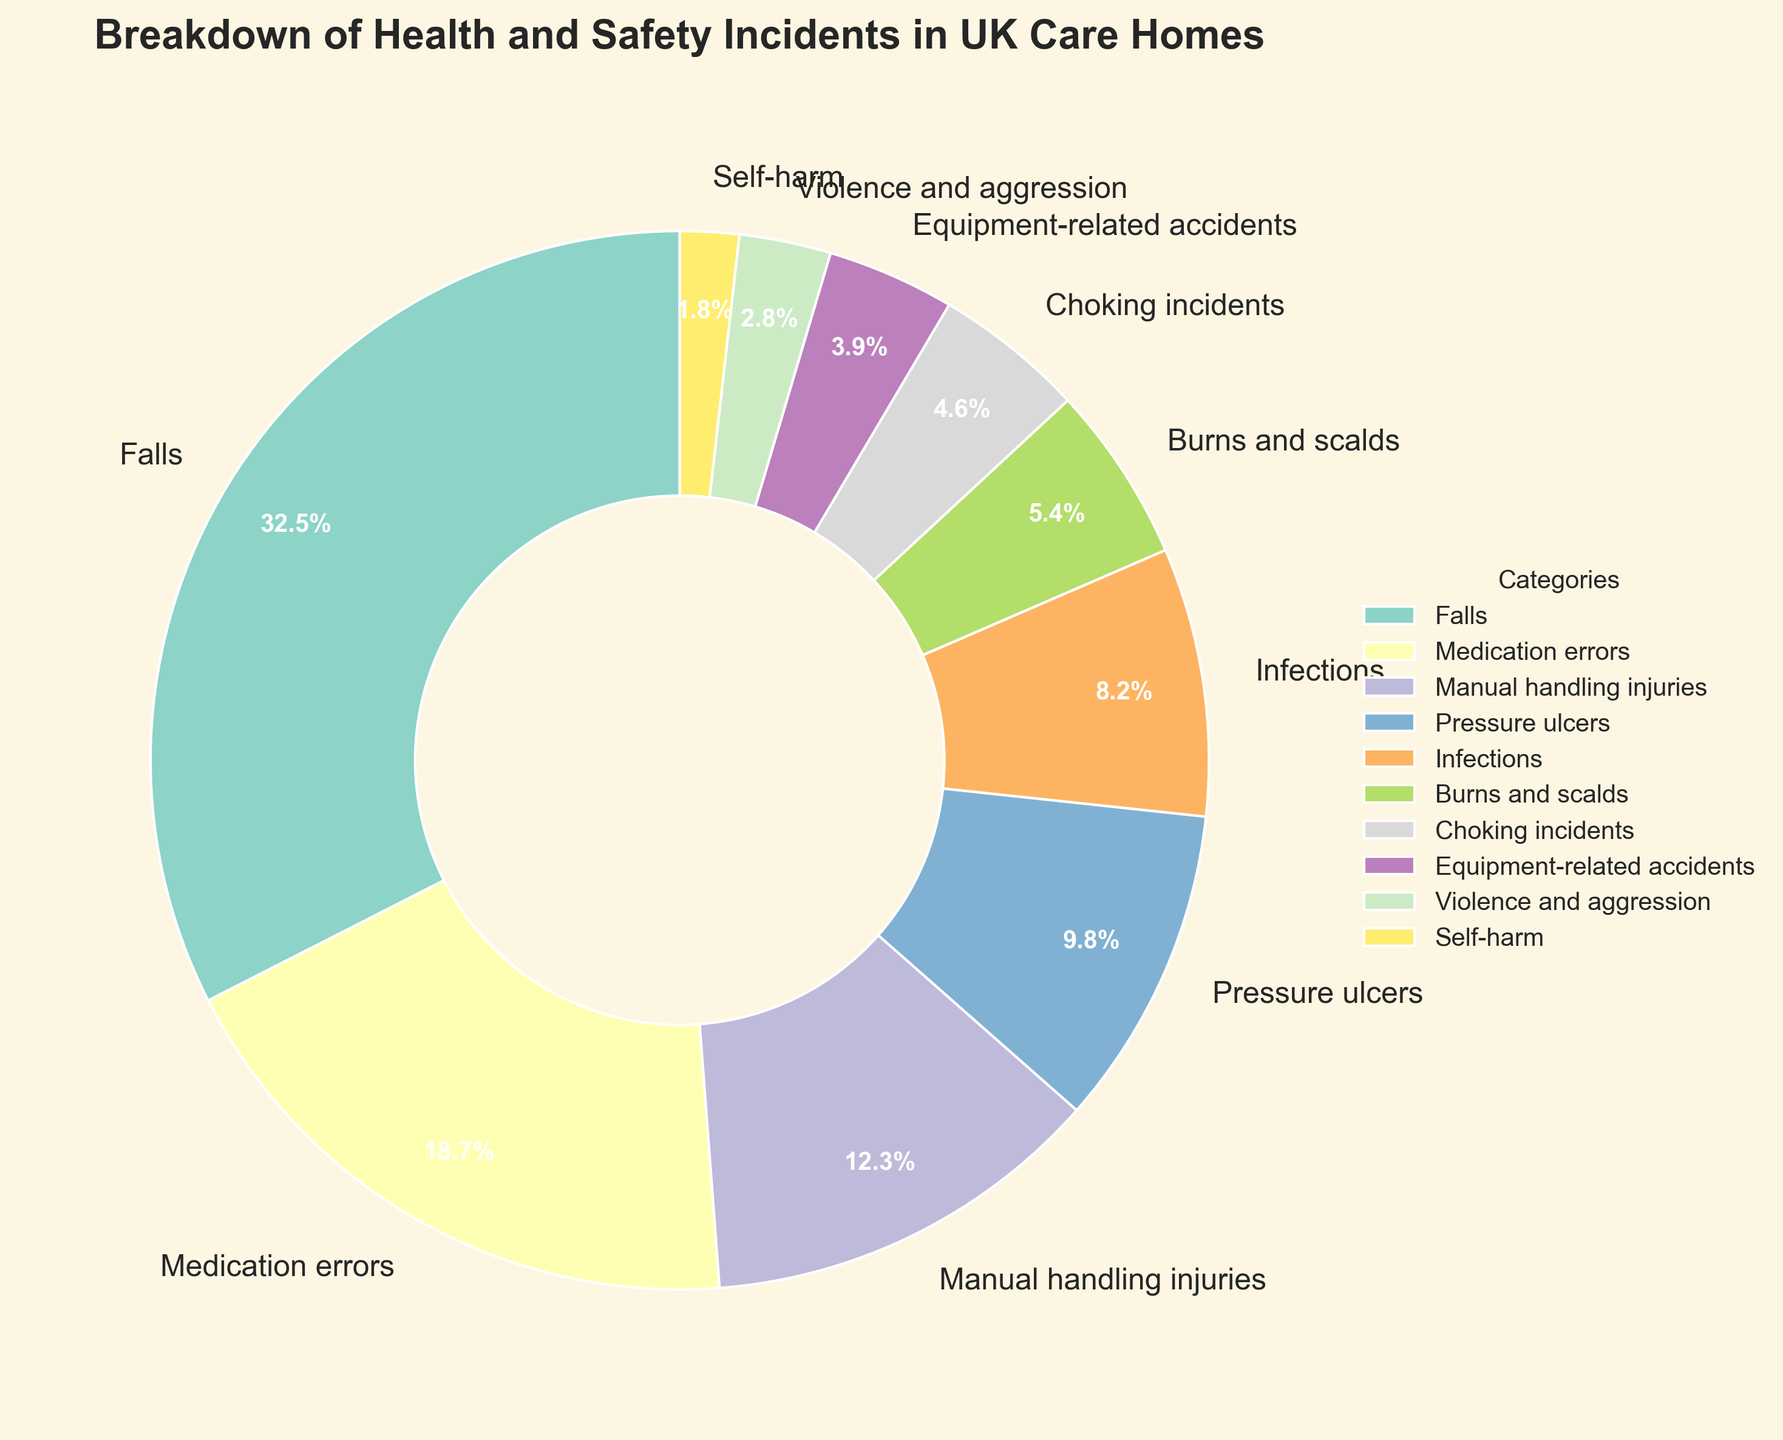How many categories have a percentage greater than 10%? Check the percentage values for each category in the pie chart and count how many exceed 10%. Falls (32.5%), Medication errors (18.7%), and Manual handling injuries (12.3%) are greater than 10%.
Answer: 3 Which category has the smallest percentage? Look for the segment with the smallest proportion in the pie chart. Self-harm has the smallest value of 1.8%.
Answer: Self-harm What's the total percentage of incidents related to infections, burns and scalds, and choking incidents? Sum the percentages for these three categories: Infections (8.2%) + Burns and scalds (5.4%) + Choking incidents (4.6%) = 18.2%.
Answer: 18.2% Is the percentage of falls greater than the combined percentages of equipment-related accidents and violence/aggression? Compare the percentage of falls (32.5%) with the sum of equipment-related accidents (3.9%) and violence/aggression (2.8%). Falls (32.5%) > Equipment-related accidents + Violence/aggression (6.7%).
Answer: Yes What is the difference in percentage between manual handling injuries and pressure ulcers? Subtract the percentage of pressure ulcers (9.8%) from the manual handling injuries (12.3%). 12.3% - 9.8% = 2.5%.
Answer: 2.5% What percentage of the incidents fall under the categories related to physical harm (falls, burns and scalds, manual handling injuries, self-harm, choking incidents)? Add the percentages of these categories: Falls (32.5%) + Burns and scalds (5.4%) + Manual handling injuries (12.3%) + Self-harm (1.8%) + Choking incidents (4.6%) = 56.6%.
Answer: 56.6% What is the overall percentage of incidents that are not related to medication errors or infections? Subtract the sum of medication errors (18.7%) and infections (8.2%) from 100%. 100% - (18.7% + 8.2%) = 73.1%.
Answer: 73.1% Which two categories are closest in terms of their percentage values? Compare the percentage values and look for the smallest difference: Choking incidents (4.6%) and Equipment-related accidents (3.9%) have a difference of 0.7%.
Answer: Choking incidents and Equipment-related accidents 